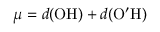<formula> <loc_0><loc_0><loc_500><loc_500>\mu = d ( O H ) + d ( O ^ { \prime } H )</formula> 